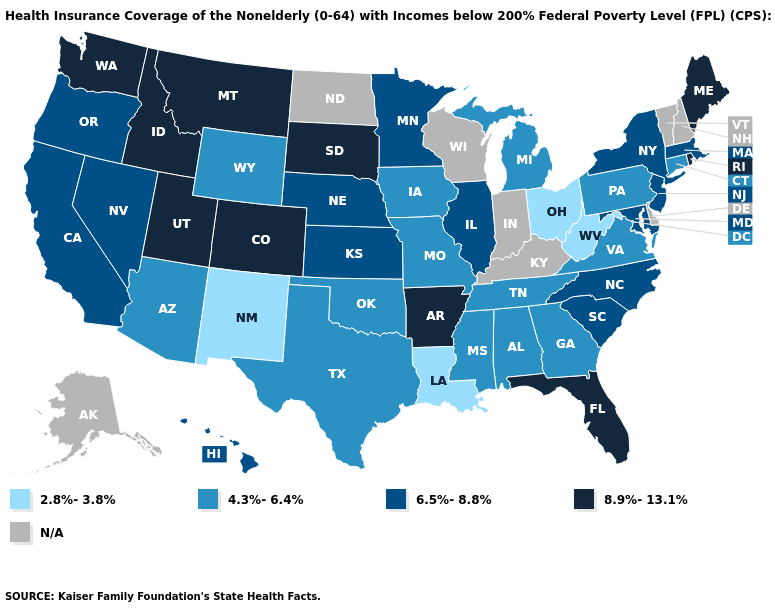Is the legend a continuous bar?
Answer briefly. No. What is the value of Virginia?
Concise answer only. 4.3%-6.4%. What is the value of Idaho?
Concise answer only. 8.9%-13.1%. Name the states that have a value in the range 2.8%-3.8%?
Keep it brief. Louisiana, New Mexico, Ohio, West Virginia. What is the value of North Dakota?
Be succinct. N/A. How many symbols are there in the legend?
Give a very brief answer. 5. Name the states that have a value in the range 8.9%-13.1%?
Be succinct. Arkansas, Colorado, Florida, Idaho, Maine, Montana, Rhode Island, South Dakota, Utah, Washington. What is the lowest value in the MidWest?
Give a very brief answer. 2.8%-3.8%. What is the value of Idaho?
Write a very short answer. 8.9%-13.1%. Name the states that have a value in the range 2.8%-3.8%?
Short answer required. Louisiana, New Mexico, Ohio, West Virginia. Is the legend a continuous bar?
Be succinct. No. Name the states that have a value in the range 6.5%-8.8%?
Quick response, please. California, Hawaii, Illinois, Kansas, Maryland, Massachusetts, Minnesota, Nebraska, Nevada, New Jersey, New York, North Carolina, Oregon, South Carolina. Does the first symbol in the legend represent the smallest category?
Keep it brief. Yes. Among the states that border Nebraska , does Missouri have the lowest value?
Give a very brief answer. Yes. 